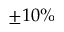Convert formula to latex. <formula><loc_0><loc_0><loc_500><loc_500>\pm 1 0 \%</formula> 